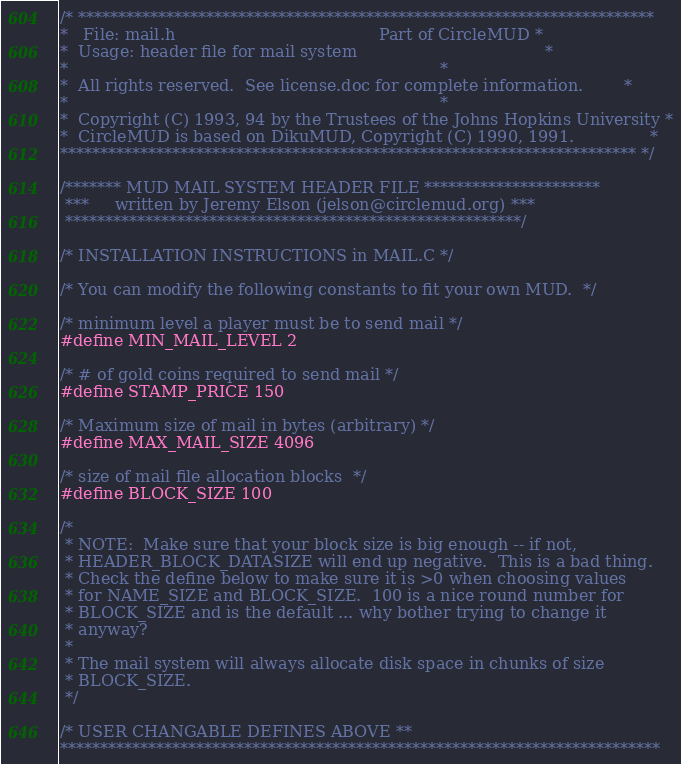Convert code to text. <code><loc_0><loc_0><loc_500><loc_500><_C_>/* ************************************************************************
*   File: mail.h                                        Part of CircleMUD *
*  Usage: header file for mail system                                     *
*                                                                         *
*  All rights reserved.  See license.doc for complete information.        *
*                                                                         *
*  Copyright (C) 1993, 94 by the Trustees of the Johns Hopkins University *
*  CircleMUD is based on DikuMUD, Copyright (C) 1990, 1991.               *
************************************************************************ */

/******* MUD MAIL SYSTEM HEADER FILE **********************
 ***     written by Jeremy Elson (jelson@circlemud.org) ***
 *********************************************************/

/* INSTALLATION INSTRUCTIONS in MAIL.C */

/* You can modify the following constants to fit your own MUD.  */

/* minimum level a player must be to send mail */
#define MIN_MAIL_LEVEL 2

/* # of gold coins required to send mail */
#define STAMP_PRICE 150

/* Maximum size of mail in bytes (arbitrary) */
#define MAX_MAIL_SIZE 4096

/* size of mail file allocation blocks  */
#define BLOCK_SIZE 100

/*
 * NOTE:  Make sure that your block size is big enough -- if not,
 * HEADER_BLOCK_DATASIZE will end up negative.  This is a bad thing.
 * Check the define below to make sure it is >0 when choosing values
 * for NAME_SIZE and BLOCK_SIZE.  100 is a nice round number for
 * BLOCK_SIZE and is the default ... why bother trying to change it
 * anyway?
 *
 * The mail system will always allocate disk space in chunks of size
 * BLOCK_SIZE.
 */

/* USER CHANGABLE DEFINES ABOVE **
***************************************************************************</code> 